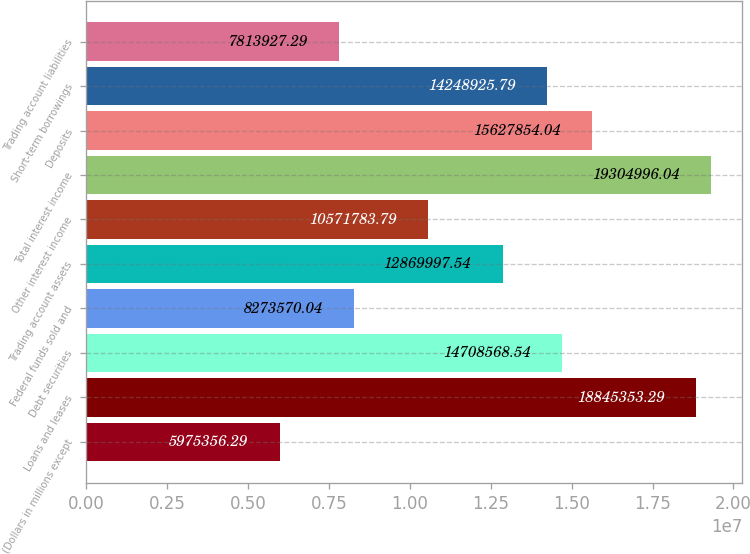<chart> <loc_0><loc_0><loc_500><loc_500><bar_chart><fcel>(Dollars in millions except<fcel>Loans and leases<fcel>Debt securities<fcel>Federal funds sold and<fcel>Trading account assets<fcel>Other interest income<fcel>Total interest income<fcel>Deposits<fcel>Short-term borrowings<fcel>Trading account liabilities<nl><fcel>5.97536e+06<fcel>1.88454e+07<fcel>1.47086e+07<fcel>8.27357e+06<fcel>1.287e+07<fcel>1.05718e+07<fcel>1.9305e+07<fcel>1.56279e+07<fcel>1.42489e+07<fcel>7.81393e+06<nl></chart> 